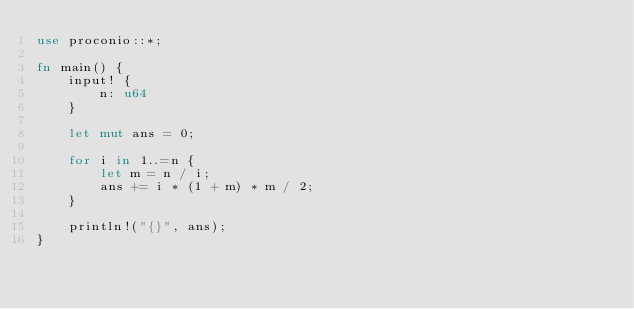Convert code to text. <code><loc_0><loc_0><loc_500><loc_500><_Rust_>use proconio::*;

fn main() {
    input! {
        n: u64
    }

    let mut ans = 0;

    for i in 1..=n {
        let m = n / i;
        ans += i * (1 + m) * m / 2;
    }

    println!("{}", ans);
}
</code> 